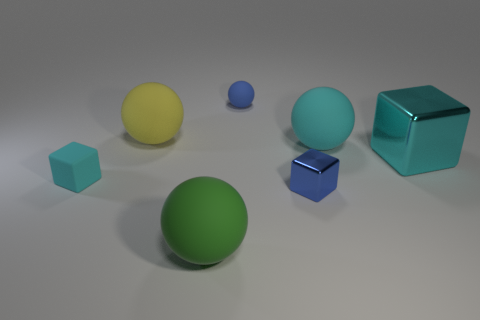Subtract all shiny cubes. How many cubes are left? 1 Subtract all blocks. How many objects are left? 4 Add 3 small cyan metallic balls. How many objects exist? 10 Subtract all green balls. How many balls are left? 3 Subtract 1 blocks. How many blocks are left? 2 Subtract all yellow cylinders. How many cyan cubes are left? 2 Subtract all tiny spheres. Subtract all blue metallic cylinders. How many objects are left? 6 Add 3 blue metal things. How many blue metal things are left? 4 Add 7 big yellow balls. How many big yellow balls exist? 8 Subtract 0 purple balls. How many objects are left? 7 